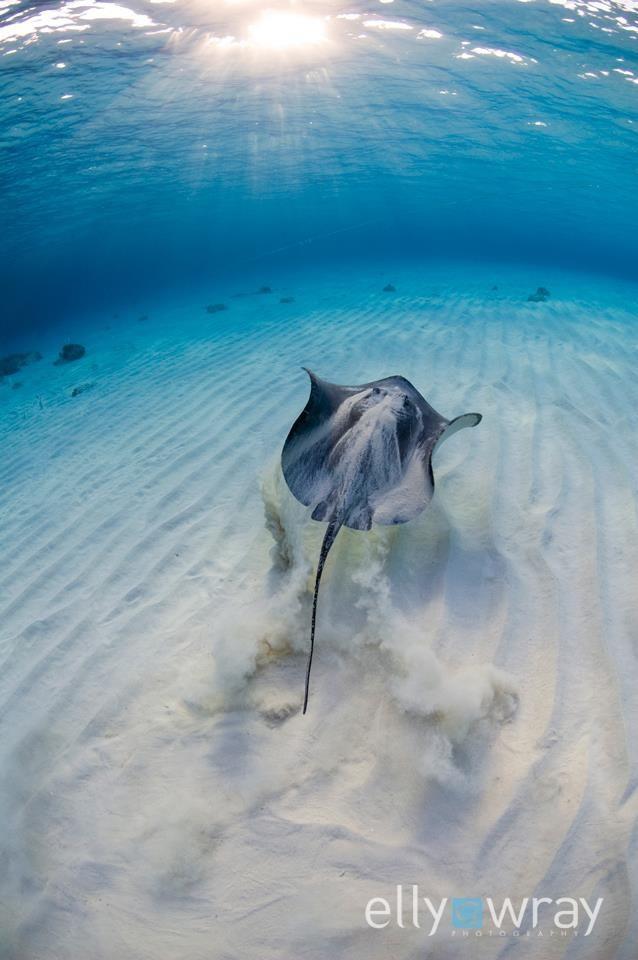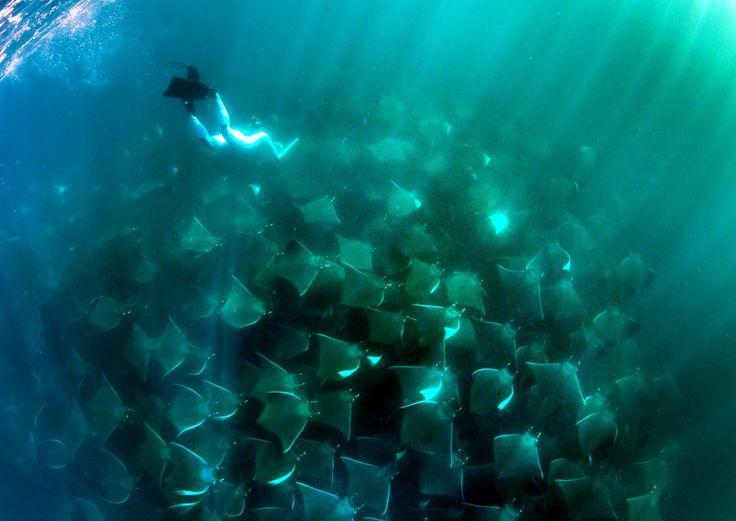The first image is the image on the left, the second image is the image on the right. Evaluate the accuracy of this statement regarding the images: "An image shows a mass of jellyfish along with something manmade that moves through the water.". Is it true? Answer yes or no. Yes. The first image is the image on the left, the second image is the image on the right. Analyze the images presented: Is the assertion "A single ray is swimming near the sand in the image on the left." valid? Answer yes or no. Yes. 